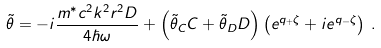<formula> <loc_0><loc_0><loc_500><loc_500>\tilde { \theta } = - i \frac { m ^ { \ast } c ^ { 2 } k ^ { 2 } r ^ { 2 } D } { 4 \hbar { \omega } } + \left ( \tilde { \theta } _ { C } C + \tilde { \theta } _ { D } D \right ) \left ( e ^ { q _ { + } \zeta } + i e ^ { q _ { - } \zeta } \right ) \, .</formula> 